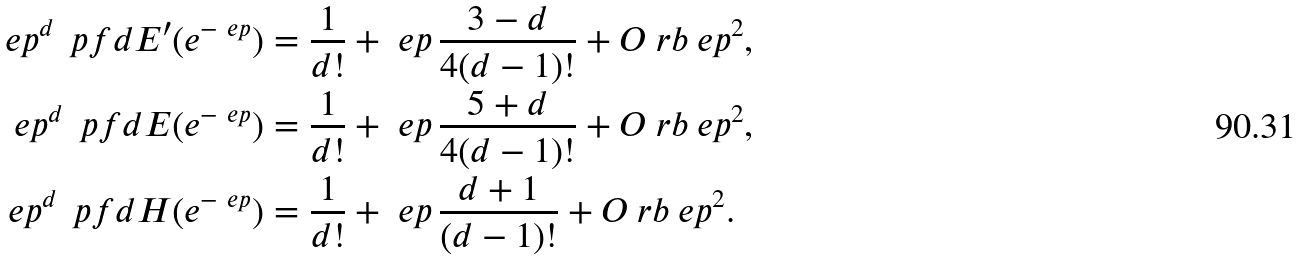<formula> <loc_0><loc_0><loc_500><loc_500>\ e p ^ { d } \, \ p f d { E ^ { \prime } ( e ^ { - \ e p } ) } & = \frac { 1 } { d ! } + \ e p \, \frac { 3 - d } { 4 ( d - 1 ) ! } + O \ r b { \ e p ^ { 2 } } , \\ \ e p ^ { d } \, \ p f d { E ( e ^ { - \ e p } ) } & = \frac { 1 } { d ! } + \ e p \, \frac { 5 + d } { 4 ( d - 1 ) ! } + O \ r b { \ e p ^ { 2 } } , \\ \ e p ^ { d } \, \ p f d { H ( e ^ { - \ e p } ) } & = \frac { 1 } { d ! } + \ e p \, \frac { d + 1 } { ( d - 1 ) ! } + O \ r b { \ e p ^ { 2 } } .</formula> 